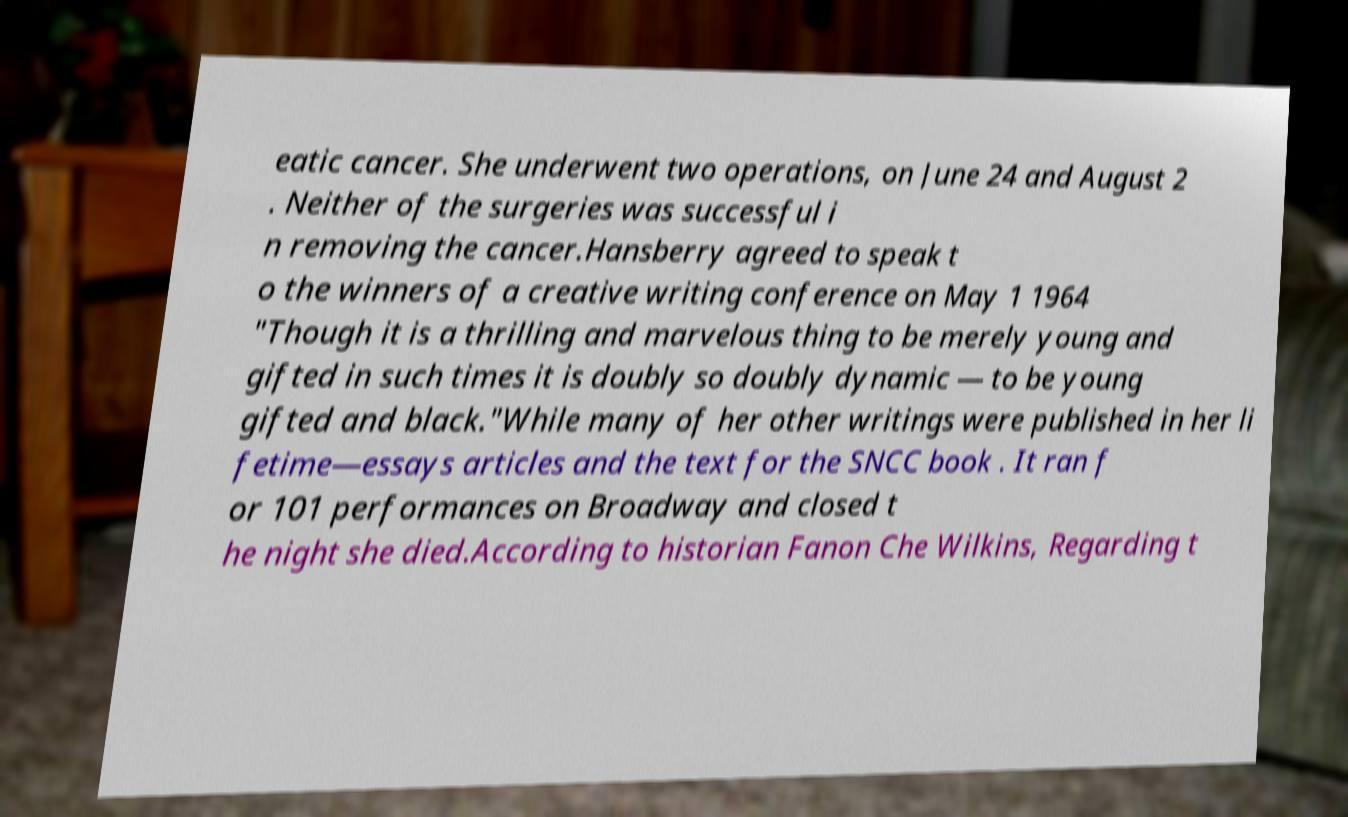I need the written content from this picture converted into text. Can you do that? eatic cancer. She underwent two operations, on June 24 and August 2 . Neither of the surgeries was successful i n removing the cancer.Hansberry agreed to speak t o the winners of a creative writing conference on May 1 1964 "Though it is a thrilling and marvelous thing to be merely young and gifted in such times it is doubly so doubly dynamic — to be young gifted and black."While many of her other writings were published in her li fetime—essays articles and the text for the SNCC book . It ran f or 101 performances on Broadway and closed t he night she died.According to historian Fanon Che Wilkins, Regarding t 